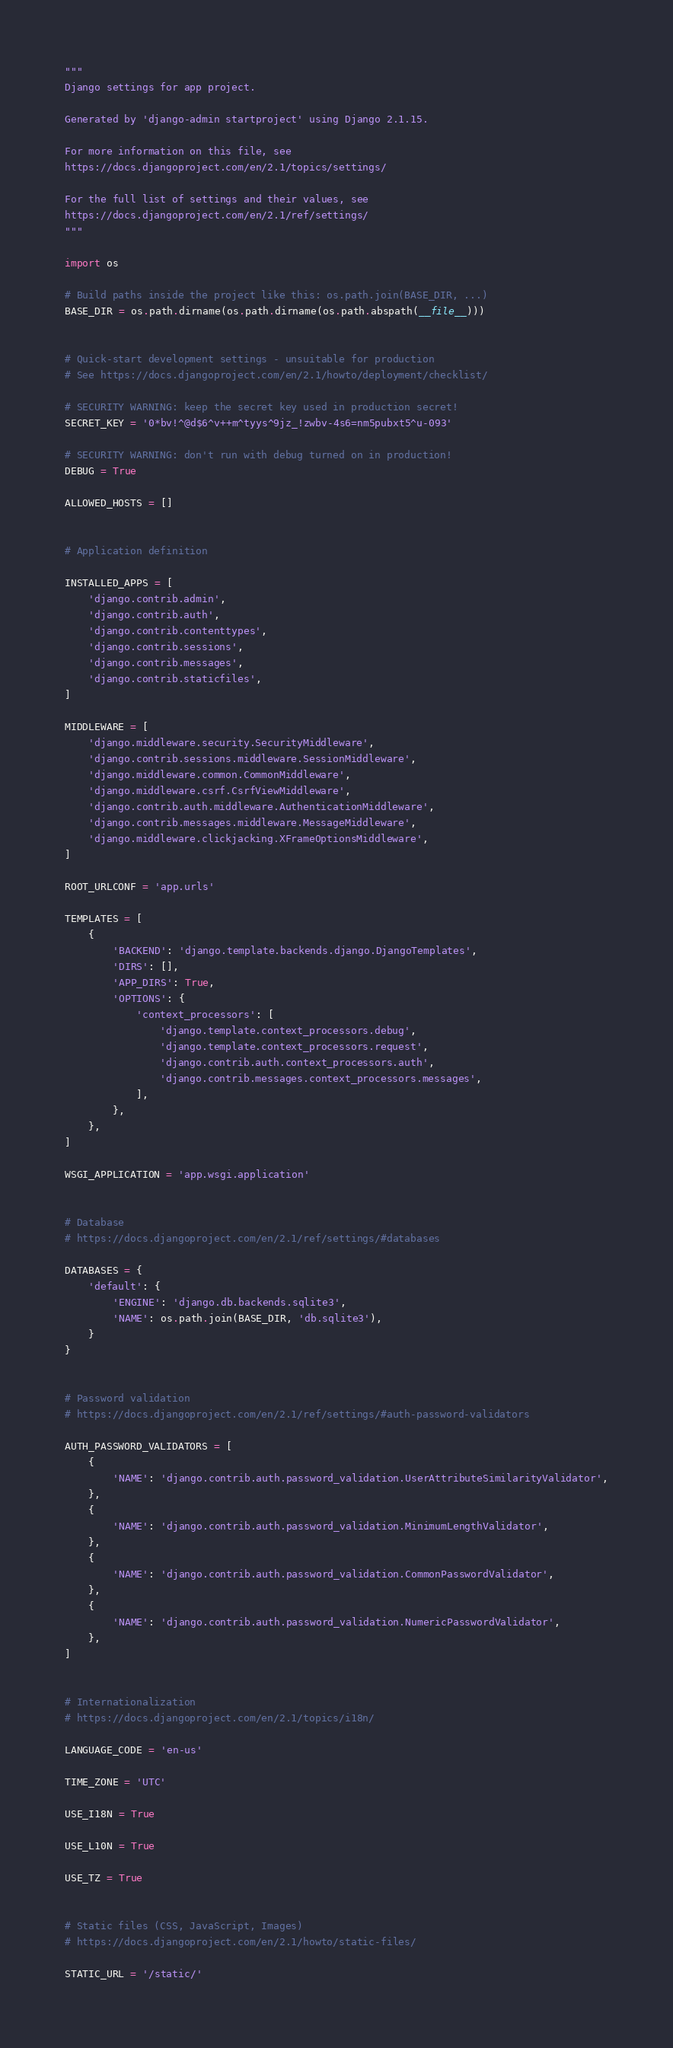Convert code to text. <code><loc_0><loc_0><loc_500><loc_500><_Python_>"""
Django settings for app project.

Generated by 'django-admin startproject' using Django 2.1.15.

For more information on this file, see
https://docs.djangoproject.com/en/2.1/topics/settings/

For the full list of settings and their values, see
https://docs.djangoproject.com/en/2.1/ref/settings/
"""

import os

# Build paths inside the project like this: os.path.join(BASE_DIR, ...)
BASE_DIR = os.path.dirname(os.path.dirname(os.path.abspath(__file__)))


# Quick-start development settings - unsuitable for production
# See https://docs.djangoproject.com/en/2.1/howto/deployment/checklist/

# SECURITY WARNING: keep the secret key used in production secret!
SECRET_KEY = '0*bv!^@d$6^v++m^tyys^9jz_!zwbv-4s6=nm5pubxt5^u-093'

# SECURITY WARNING: don't run with debug turned on in production!
DEBUG = True

ALLOWED_HOSTS = []


# Application definition

INSTALLED_APPS = [
    'django.contrib.admin',
    'django.contrib.auth',
    'django.contrib.contenttypes',
    'django.contrib.sessions',
    'django.contrib.messages',
    'django.contrib.staticfiles',
]

MIDDLEWARE = [
    'django.middleware.security.SecurityMiddleware',
    'django.contrib.sessions.middleware.SessionMiddleware',
    'django.middleware.common.CommonMiddleware',
    'django.middleware.csrf.CsrfViewMiddleware',
    'django.contrib.auth.middleware.AuthenticationMiddleware',
    'django.contrib.messages.middleware.MessageMiddleware',
    'django.middleware.clickjacking.XFrameOptionsMiddleware',
]

ROOT_URLCONF = 'app.urls'

TEMPLATES = [
    {
        'BACKEND': 'django.template.backends.django.DjangoTemplates',
        'DIRS': [],
        'APP_DIRS': True,
        'OPTIONS': {
            'context_processors': [
                'django.template.context_processors.debug',
                'django.template.context_processors.request',
                'django.contrib.auth.context_processors.auth',
                'django.contrib.messages.context_processors.messages',
            ],
        },
    },
]

WSGI_APPLICATION = 'app.wsgi.application'


# Database
# https://docs.djangoproject.com/en/2.1/ref/settings/#databases

DATABASES = {
    'default': {
        'ENGINE': 'django.db.backends.sqlite3',
        'NAME': os.path.join(BASE_DIR, 'db.sqlite3'),
    }
}


# Password validation
# https://docs.djangoproject.com/en/2.1/ref/settings/#auth-password-validators

AUTH_PASSWORD_VALIDATORS = [
    {
        'NAME': 'django.contrib.auth.password_validation.UserAttributeSimilarityValidator',
    },
    {
        'NAME': 'django.contrib.auth.password_validation.MinimumLengthValidator',
    },
    {
        'NAME': 'django.contrib.auth.password_validation.CommonPasswordValidator',
    },
    {
        'NAME': 'django.contrib.auth.password_validation.NumericPasswordValidator',
    },
]


# Internationalization
# https://docs.djangoproject.com/en/2.1/topics/i18n/

LANGUAGE_CODE = 'en-us'

TIME_ZONE = 'UTC'

USE_I18N = True

USE_L10N = True

USE_TZ = True


# Static files (CSS, JavaScript, Images)
# https://docs.djangoproject.com/en/2.1/howto/static-files/

STATIC_URL = '/static/'
</code> 